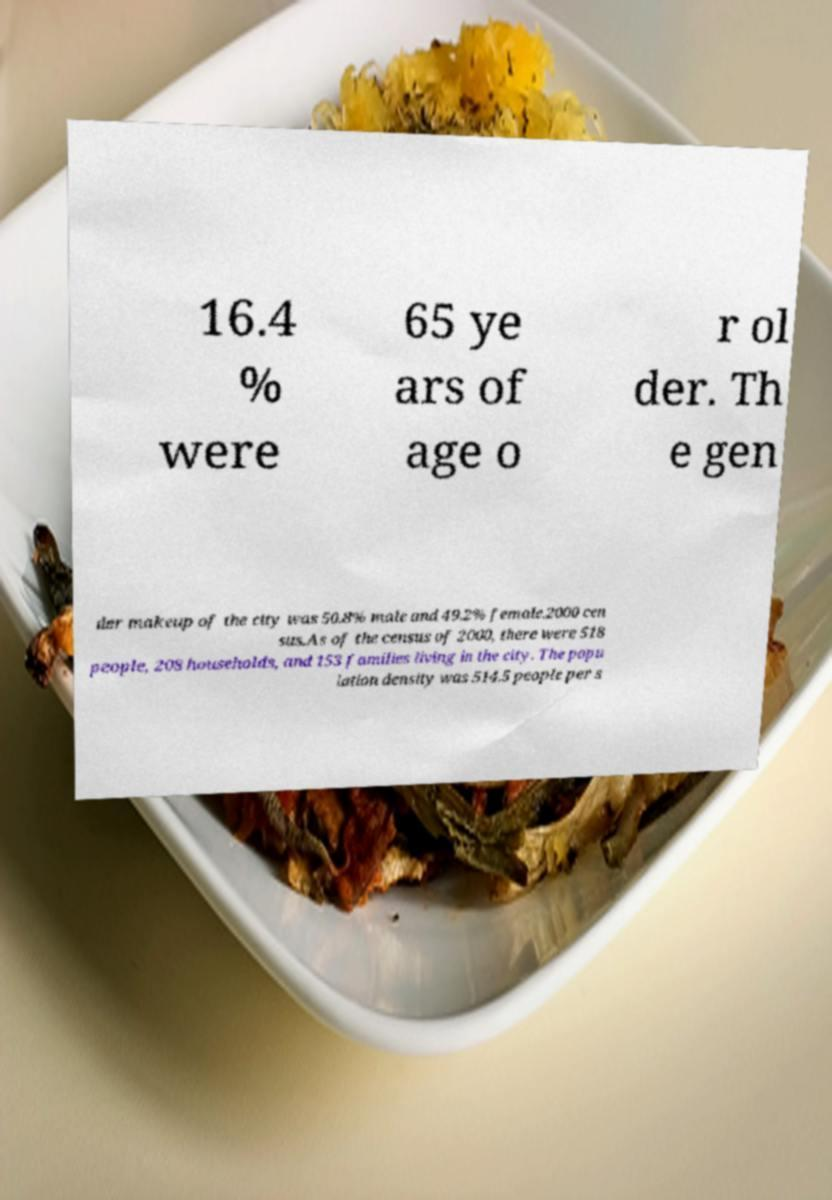Could you assist in decoding the text presented in this image and type it out clearly? 16.4 % were 65 ye ars of age o r ol der. Th e gen der makeup of the city was 50.8% male and 49.2% female.2000 cen sus.As of the census of 2000, there were 518 people, 208 households, and 153 families living in the city. The popu lation density was 514.5 people per s 